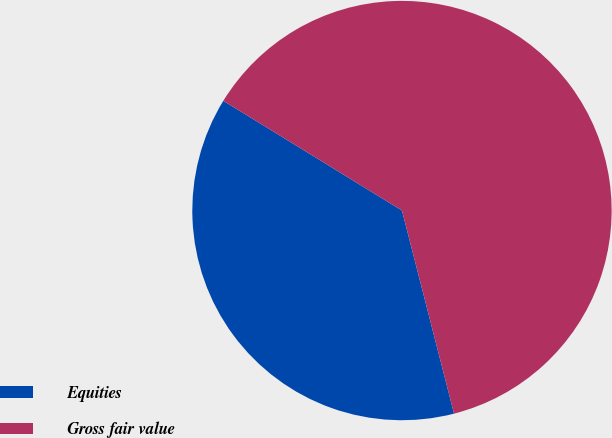<chart> <loc_0><loc_0><loc_500><loc_500><pie_chart><fcel>Equities<fcel>Gross fair value<nl><fcel>37.76%<fcel>62.24%<nl></chart> 